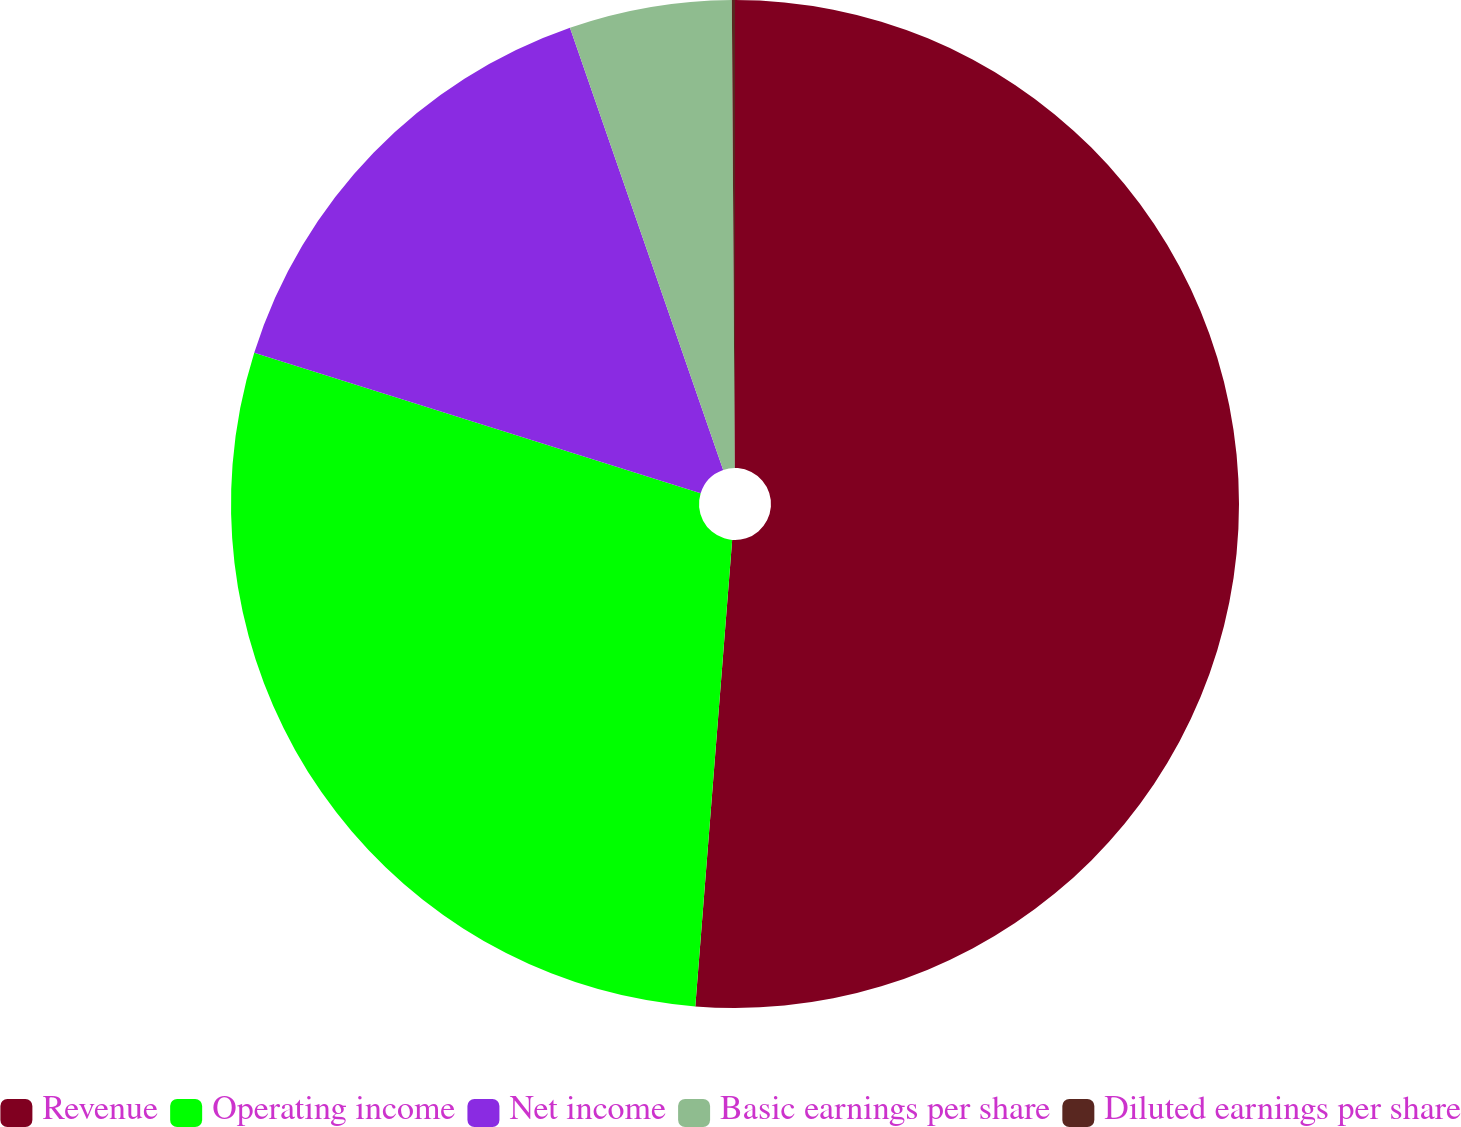Convert chart. <chart><loc_0><loc_0><loc_500><loc_500><pie_chart><fcel>Revenue<fcel>Operating income<fcel>Net income<fcel>Basic earnings per share<fcel>Diluted earnings per share<nl><fcel>51.26%<fcel>28.6%<fcel>14.84%<fcel>5.21%<fcel>0.1%<nl></chart> 